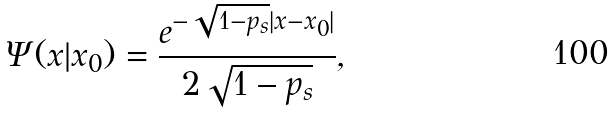Convert formula to latex. <formula><loc_0><loc_0><loc_500><loc_500>\Psi ( x | x _ { 0 } ) = \frac { e ^ { - \sqrt { 1 - p _ { s } } | x - x _ { 0 } | } } { 2 \sqrt { 1 - p _ { s } } } ,</formula> 